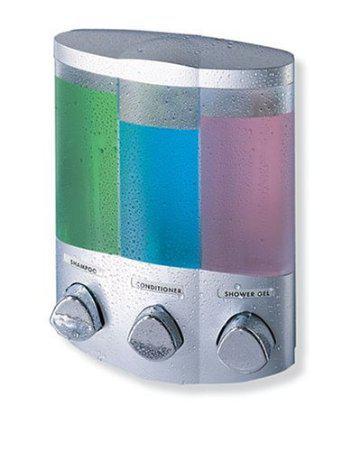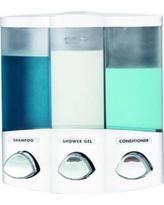The first image is the image on the left, the second image is the image on the right. Analyze the images presented: Is the assertion "The right image contains a soap dispenser and the soap container the furthest to the right is bright green." valid? Answer yes or no. Yes. 